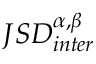Convert formula to latex. <formula><loc_0><loc_0><loc_500><loc_500>J S D _ { i n t e r } ^ { \alpha , \beta }</formula> 